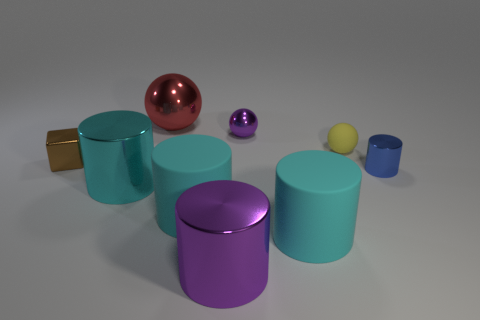There is a metallic thing that is the same color as the small shiny ball; what is its size?
Your answer should be very brief. Large. What number of other things are there of the same color as the tiny metal sphere?
Make the answer very short. 1. There is a cylinder that is to the right of the small purple thing and in front of the cyan shiny cylinder; what color is it?
Offer a very short reply. Cyan. Is the number of large cyan shiny cylinders less than the number of large red cylinders?
Offer a very short reply. No. There is a small matte thing; does it have the same color as the big shiny cylinder to the left of the large purple metal cylinder?
Keep it short and to the point. No. Are there an equal number of purple metallic cylinders in front of the small metallic ball and blue shiny cylinders that are behind the large red shiny sphere?
Ensure brevity in your answer.  No. How many purple metal objects are the same shape as the big red shiny thing?
Your answer should be very brief. 1. Are any tiny gray rubber cubes visible?
Your answer should be very brief. No. Do the brown cube and the tiny object in front of the cube have the same material?
Your response must be concise. Yes. There is a cylinder that is the same size as the shiny block; what material is it?
Provide a short and direct response. Metal. 